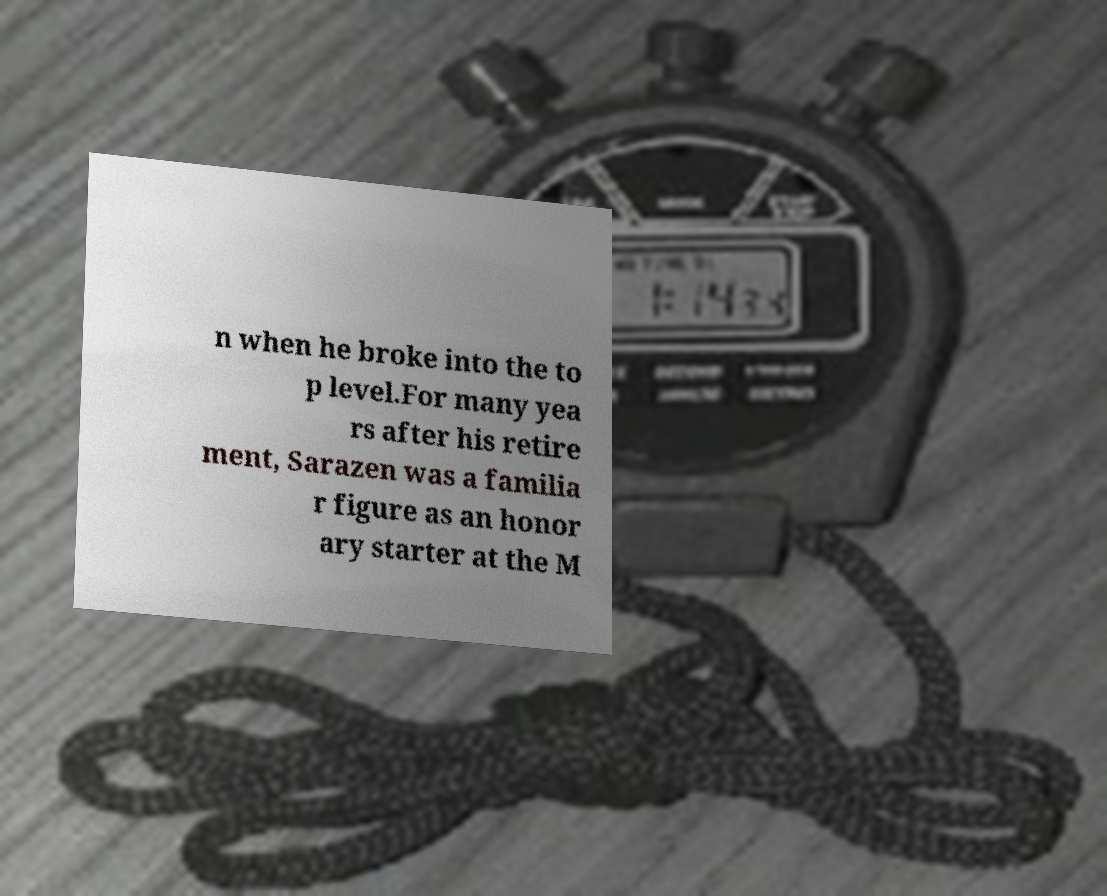Can you accurately transcribe the text from the provided image for me? n when he broke into the to p level.For many yea rs after his retire ment, Sarazen was a familia r figure as an honor ary starter at the M 